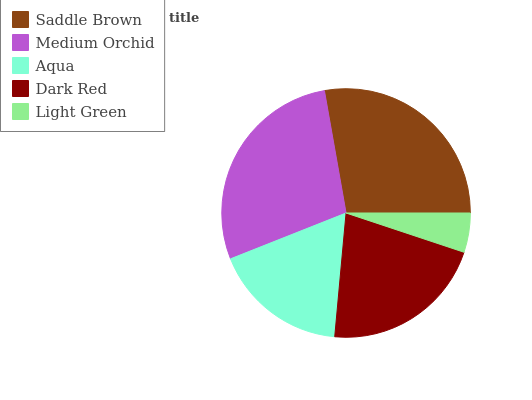Is Light Green the minimum?
Answer yes or no. Yes. Is Medium Orchid the maximum?
Answer yes or no. Yes. Is Aqua the minimum?
Answer yes or no. No. Is Aqua the maximum?
Answer yes or no. No. Is Medium Orchid greater than Aqua?
Answer yes or no. Yes. Is Aqua less than Medium Orchid?
Answer yes or no. Yes. Is Aqua greater than Medium Orchid?
Answer yes or no. No. Is Medium Orchid less than Aqua?
Answer yes or no. No. Is Dark Red the high median?
Answer yes or no. Yes. Is Dark Red the low median?
Answer yes or no. Yes. Is Aqua the high median?
Answer yes or no. No. Is Aqua the low median?
Answer yes or no. No. 